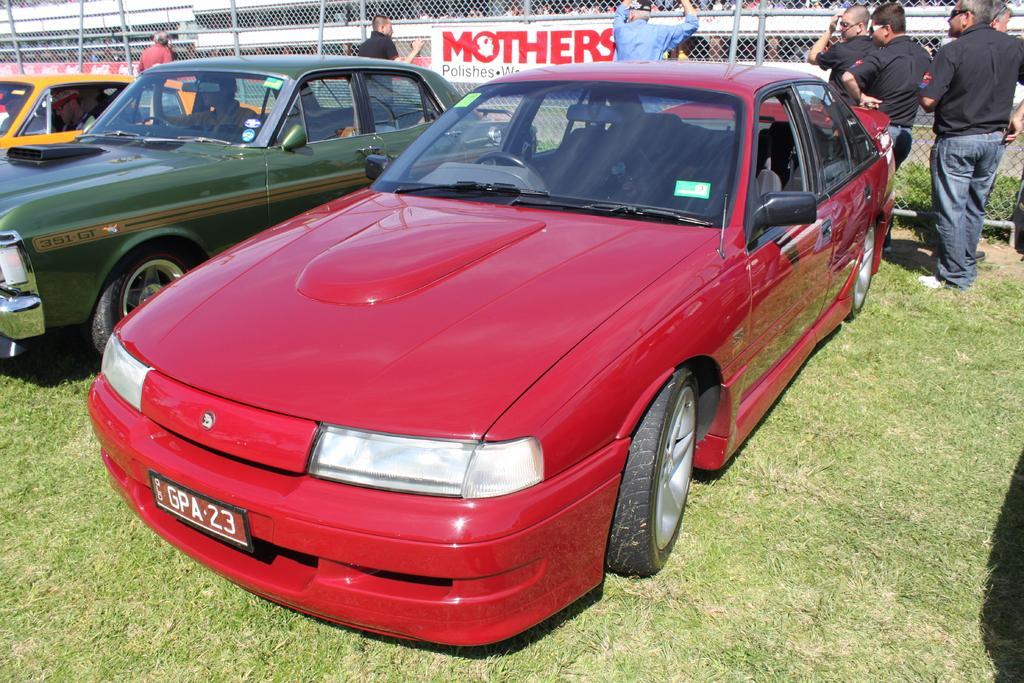How would you summarize this image in a sentence or two? In this picture there are three cars with red, green and yellow colors. They are on the grass. Behind the car there are some people standing. And there is a poster in the middle. Inside the green color car there is a man sitting. 